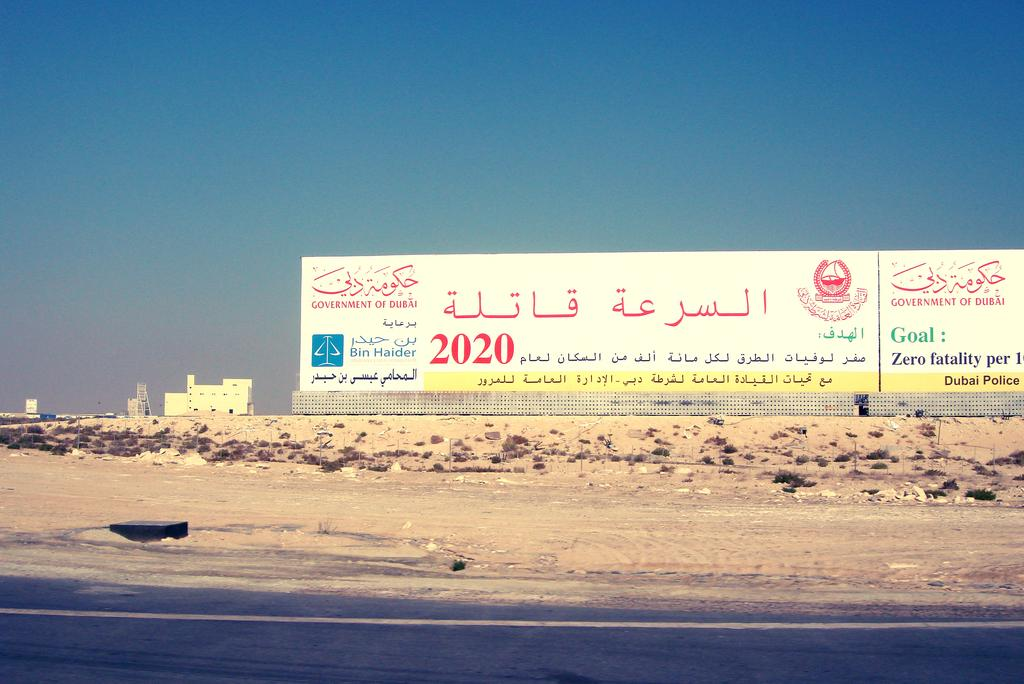<image>
Render a clear and concise summary of the photo. A sign in Arabic with the name Bin Haider sits on dry soil by the road. 